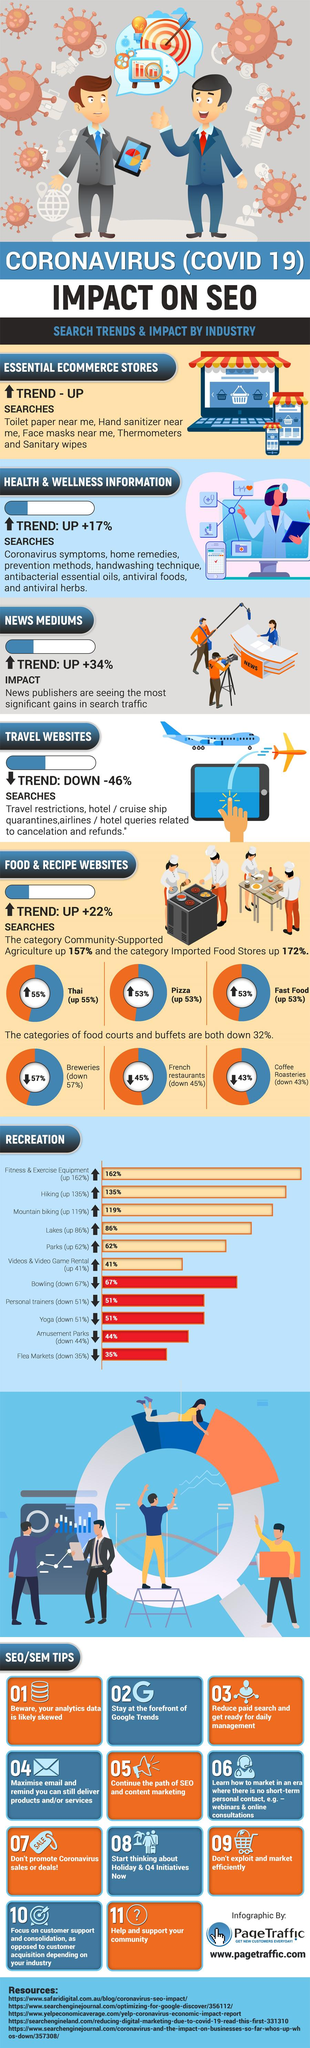List a handful of essential elements in this visual. There has been a significant increase of 57% in coffee roasteries. The number of breweries in the area has increased by 43%. In Thai cuisine, approximately 45% of dishes contain some form of chili peppers. Forty-seven percent of the Pizza is down. 